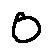Convert formula to latex. <formula><loc_0><loc_0><loc_500><loc_500>0</formula> 